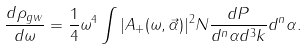Convert formula to latex. <formula><loc_0><loc_0><loc_500><loc_500>\frac { d \rho _ { g w } } { d \omega } = \frac { 1 } { 4 } \omega ^ { 4 } \int | A _ { + } ( \omega , \vec { \alpha } ) | ^ { 2 } N \frac { d P } { d ^ { n } \alpha d ^ { 3 } k } d ^ { n } \alpha .</formula> 